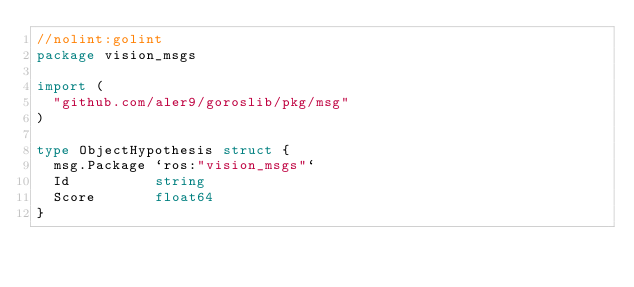Convert code to text. <code><loc_0><loc_0><loc_500><loc_500><_Go_>//nolint:golint
package vision_msgs

import (
	"github.com/aler9/goroslib/pkg/msg"
)

type ObjectHypothesis struct {
	msg.Package `ros:"vision_msgs"`
	Id          string
	Score       float64
}
</code> 